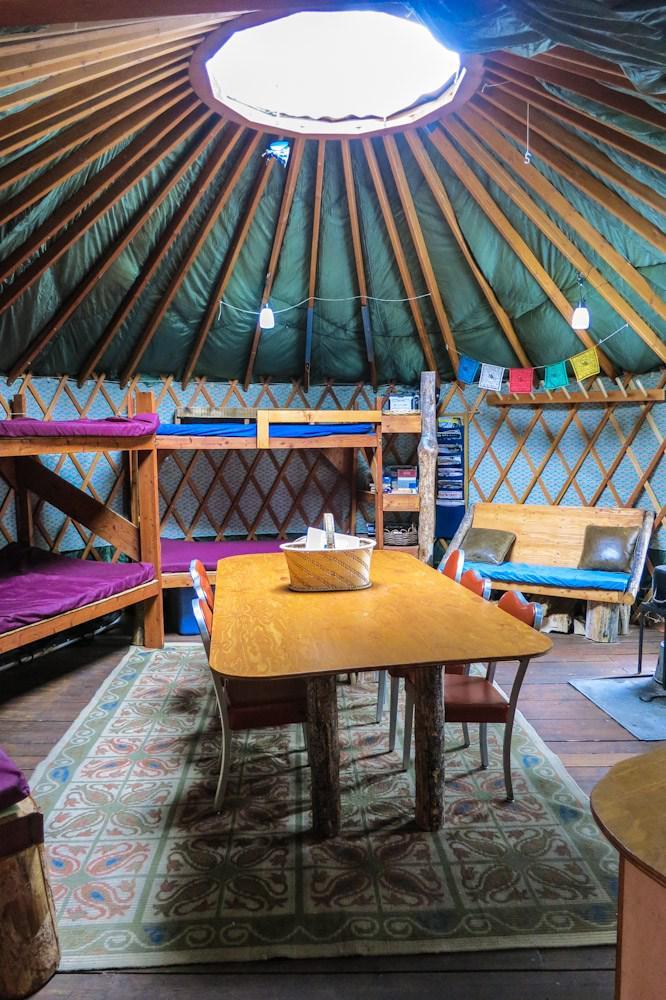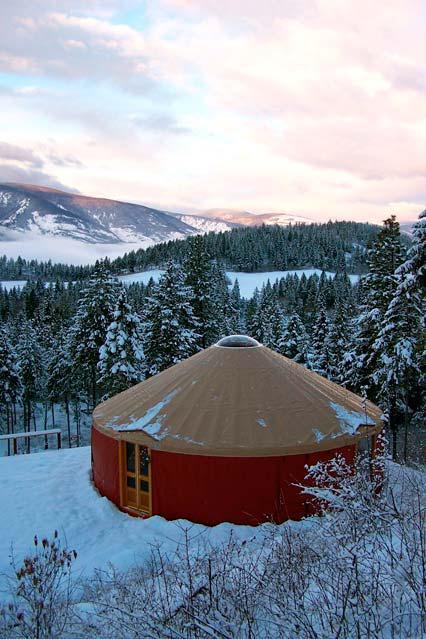The first image is the image on the left, the second image is the image on the right. Assess this claim about the two images: "One of the images is of the outside of a yurt, and the other is of the inside, and there is no snow visible in either of them.". Correct or not? Answer yes or no. No. 